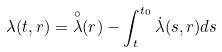<formula> <loc_0><loc_0><loc_500><loc_500>\lambda ( t , r ) = \overset { \circ } { \lambda } ( r ) - \int _ { t } ^ { t _ { 0 } } \dot { \lambda } ( s , r ) d s</formula> 